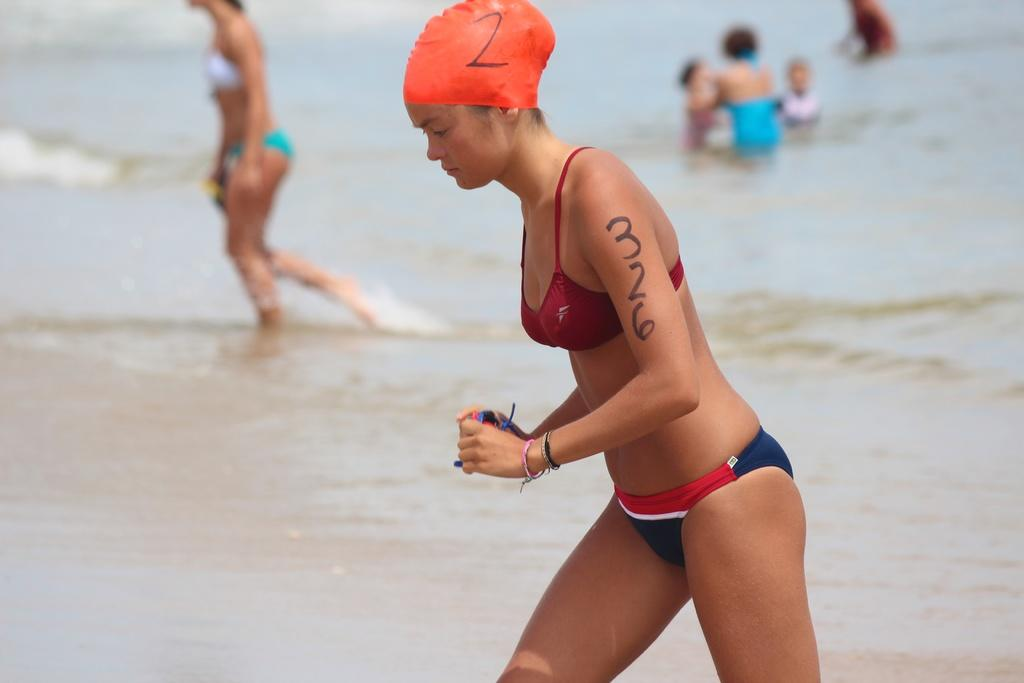Who is present in the image? There are people in the image. What are the people doing at the beach? The people are walking and playing. What type of clothing are the people wearing? The people are wearing swimsuits. What type of crate can be seen on the beach in the image? There is no crate present in the image. How many beads are scattered on the beach in the image? There are no beads present in the image. 